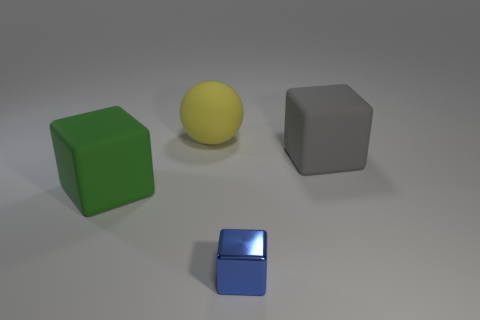How do you think the size of the blocks compares to each other? The green block is the largest, followed by the grey block, which seems to be of a similar size but is slightly obscured due to perspective. The yellow sphere acts as a midpoint in size, while the blue block is clearly the smallest item in the collection, detailed by its sharp reflections indicating its compact form. 